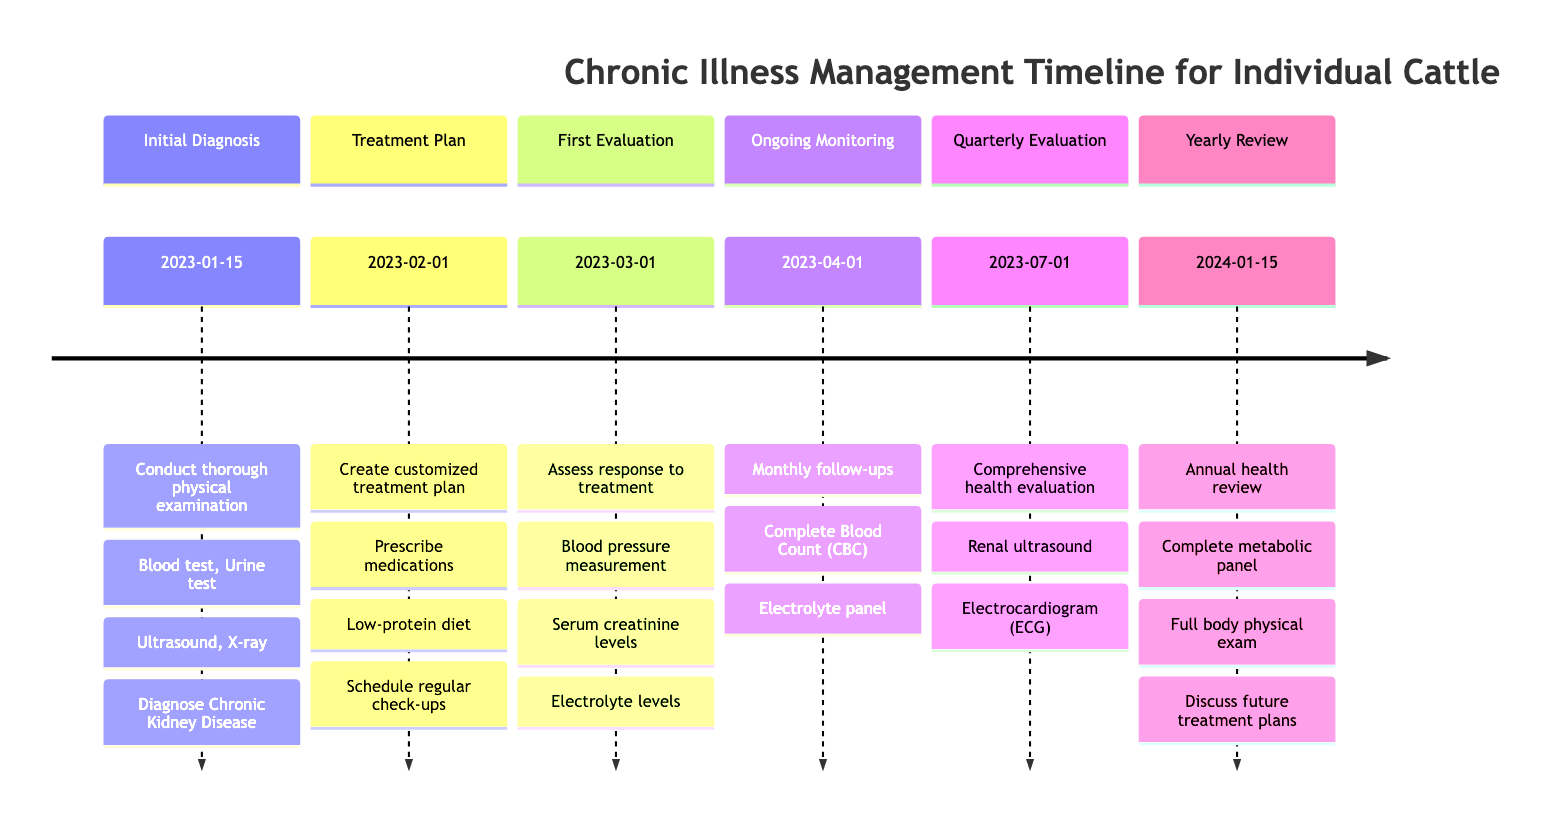What is the initial diagnosis date? The timeline indicates that the initial diagnosis was made on January 15, 2023. This can be found in the section labeled "Initial Diagnosis."
Answer: January 15, 2023 How many diagnostic tests were conducted during the initial diagnosis? The initial diagnosis includes four diagnostic tests: blood test, urine test, ultrasound, and X-ray. This is listed under the "Initial Diagnosis" step.
Answer: Four What is the main diagnosis made for the cattle? The main diagnosis derived from the timeline is "Chronic Kidney Disease," stated in the "Initial Diagnosis" section.
Answer: Chronic Kidney Disease What medications were prescribed in the treatment plan? The treatment plan includes two main medications: ACE inhibitors and phosphate binders, which are clearly listed in the "Treatment Plan Development" section.
Answer: ACE inhibitors, phosphate binders What tests are included in the first health evaluation? The first health evaluation involves measuring blood pressure, checking serum creatinine levels, and evaluating electrolyte levels, as detailed in the "First Health Evaluation" section.
Answer: Blood pressure measurement, serum creatinine levels, electrolyte levels How often are the ongoing treatments monitored? Ongoing treatments are monitored on a monthly basis, as indicated in the "Ongoing Treatment Monitoring" section where the frequency of follow-ups is specified.
Answer: Monthly What type of tests are conducted during the quarterly health evaluation? The quarterly health evaluation includes a renal ultrasound and an electrocardiogram (ECG), which are explicitly listed in the "Quarterly Health Evaluation" section.
Answer: Renal ultrasound, electrocardiogram (ECG) When is the yearly health review scheduled? The yearly health review is scheduled for January 15, 2024, as indicated in the "Yearly Health Review" section of the timeline.
Answer: January 15, 2024 What is the action taken during the ongoing treatment monitoring? The action taken during ongoing treatment monitoring is to have regular follow-ups and monitoring every month, as outlined in the "Ongoing Treatment Monitoring" section.
Answer: Regular follow-ups and monitoring 